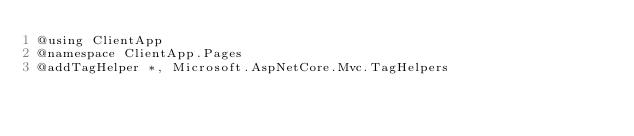<code> <loc_0><loc_0><loc_500><loc_500><_C#_>@using ClientApp
@namespace ClientApp.Pages
@addTagHelper *, Microsoft.AspNetCore.Mvc.TagHelpers
</code> 